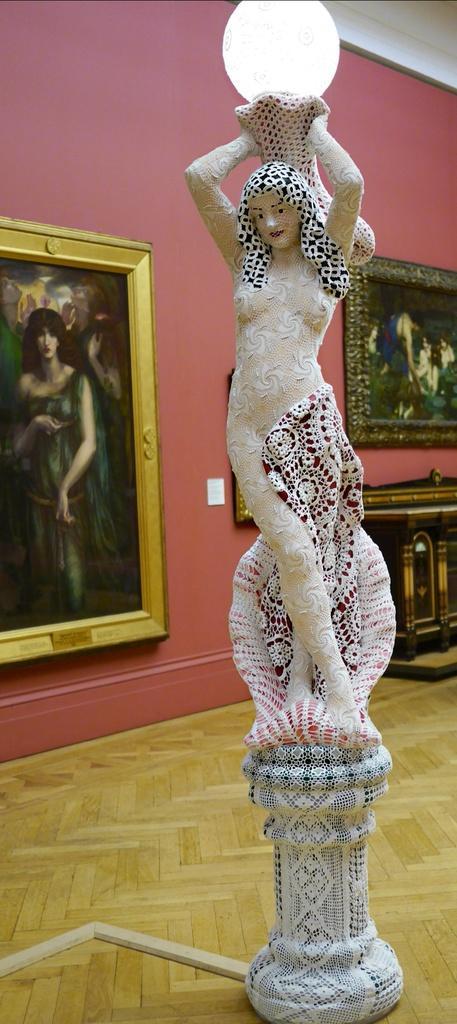In one or two sentences, can you explain what this image depicts? In the picture we can see a sculpture of a woman holding a light and behind it we can see a wall with some photo frames and some painting on it. 